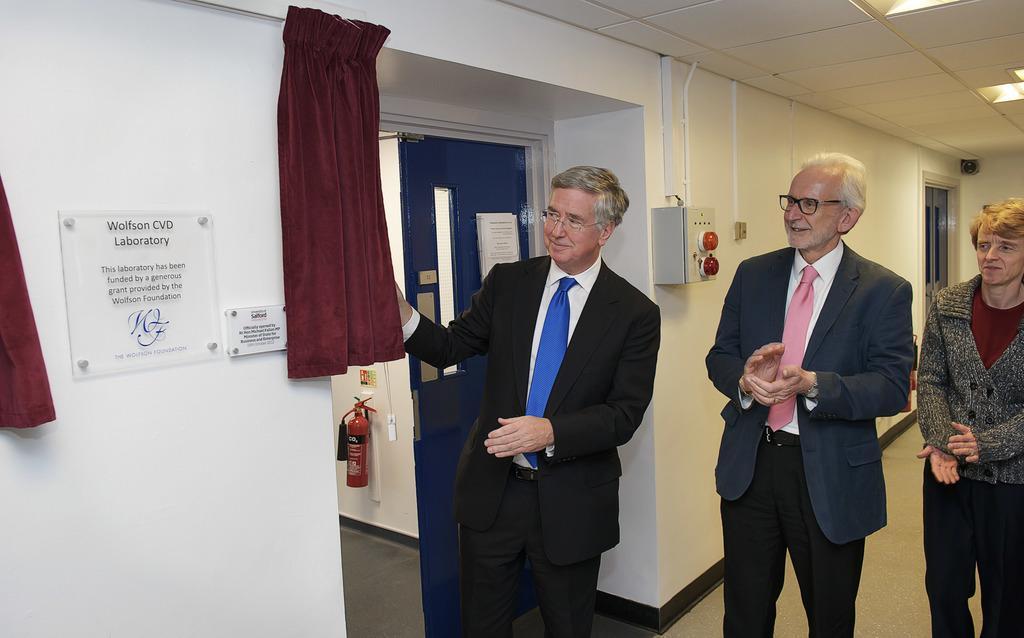How would you summarize this image in a sentence or two? This is inside view. On the right side there are three persons standing and smiling by looking at the board which is attached to the wall on the left side. Beside the board I can see the curtains. In the background there is a metal box attached to the wall. At the back of these people there is a door. At the top there are few lights. 